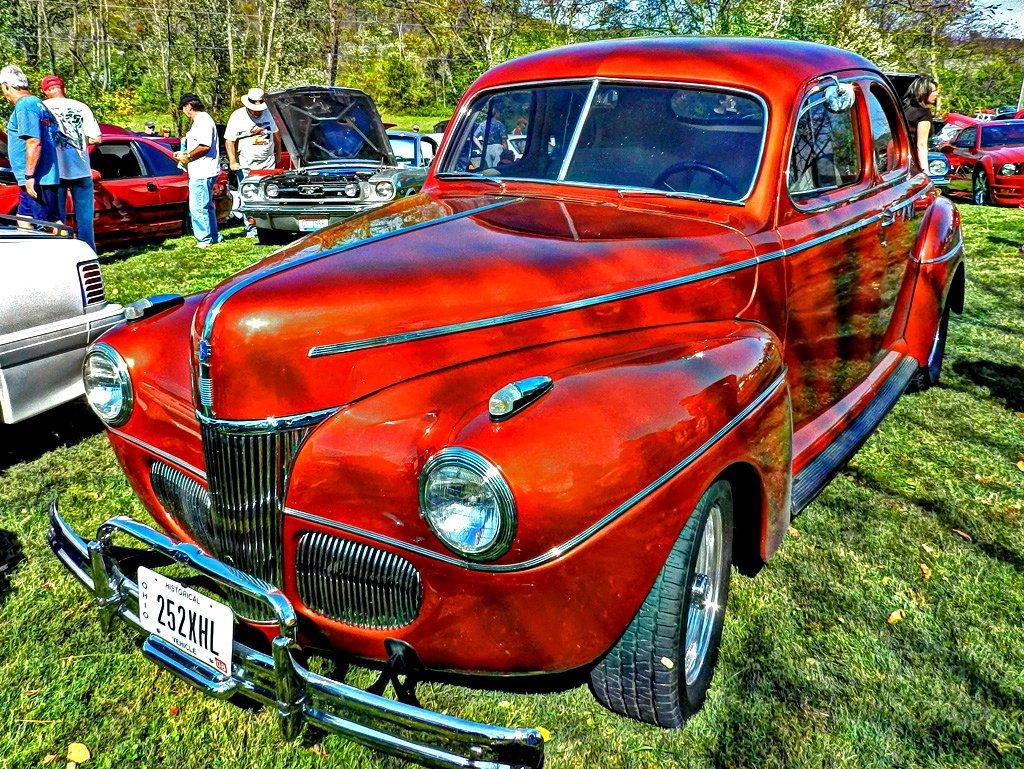What type of vehicles can be seen in the image? There are cars in the image. Who or what else is present in the image? There are people in the image. What type of vegetation is visible at the bottom of the image? There is grass at the bottom of the image. What can be seen in the background of the image? There are trees and the sky visible in the background of the image. What type of plastic object is being used for balance in the image? There is no plastic object being used for balance in the image. 